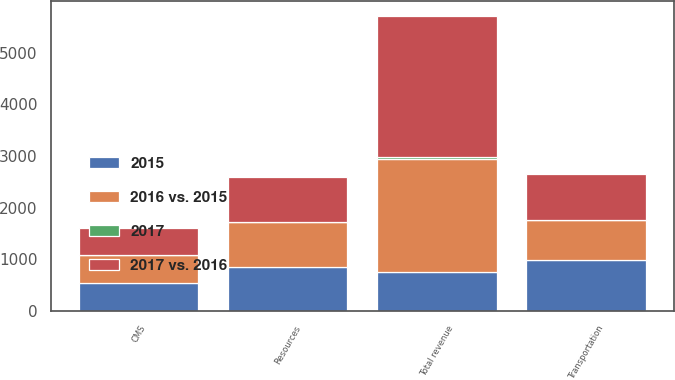<chart> <loc_0><loc_0><loc_500><loc_500><stacked_bar_chart><ecel><fcel>Resources<fcel>Transportation<fcel>CMS<fcel>Total revenue<nl><fcel>2015<fcel>839.3<fcel>991.6<fcel>535.9<fcel>758.4<nl><fcel>2017 vs. 2016<fcel>860.8<fcel>892.8<fcel>532.2<fcel>2734.8<nl><fcel>2016 vs. 2015<fcel>884.6<fcel>758.4<fcel>541.3<fcel>2184.3<nl><fcel>2017<fcel>2<fcel>11<fcel>1<fcel>32<nl></chart> 